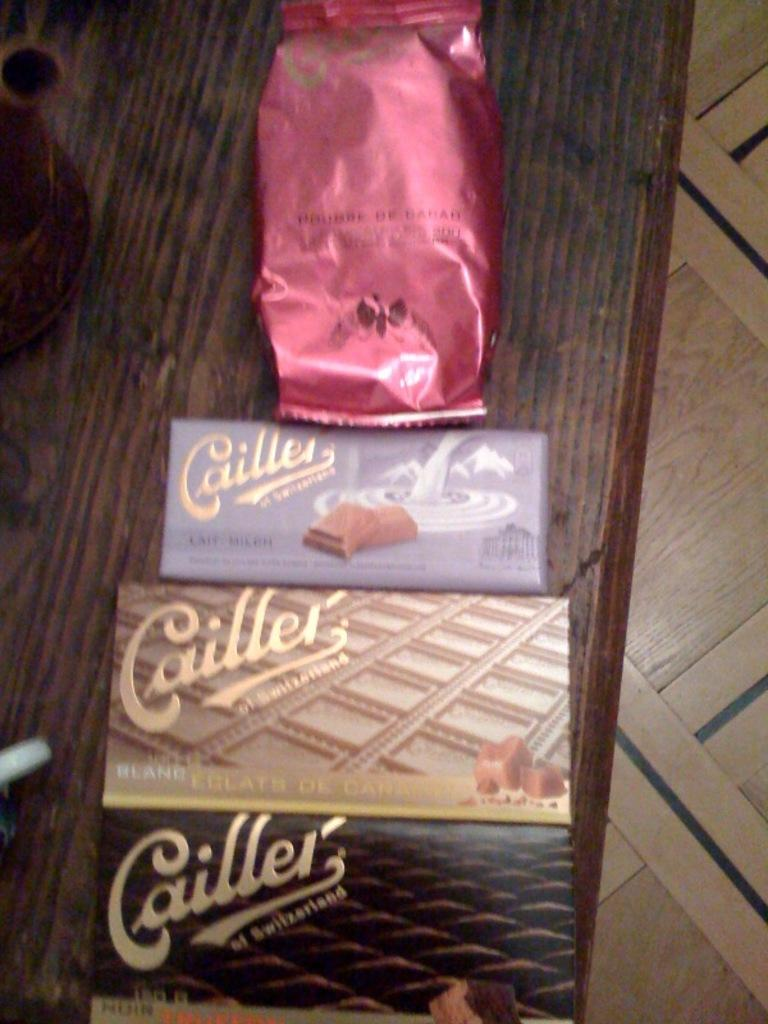What type of food is present on the table in the image? There are chocolates on a table in the image. Where are the chocolates located on the table? The chocolates are in the center of the image. What type of government is depicted in the image? There is no government depicted in the image; it features chocolates on a table. What kind of cable can be seen connecting the chocolates in the image? There is no cable present in the image; it only shows chocolates on a table. 